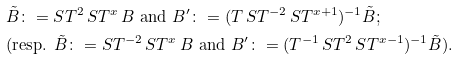<formula> <loc_0><loc_0><loc_500><loc_500>& \tilde { B } \colon = S T ^ { 2 } \, S T ^ { x } \, B \text { and } B ^ { \prime } \colon = ( T \, S T ^ { - 2 } \, S T ^ { x + 1 } ) ^ { - 1 } \tilde { B } ; \\ & ( \text {resp. } \tilde { B } \colon = S T ^ { - 2 } \, S T ^ { x } \, B \text { and } B ^ { \prime } \colon = ( T ^ { - 1 } \, S T ^ { 2 } \, S T ^ { x - 1 } ) ^ { - 1 } \tilde { B } ) .</formula> 